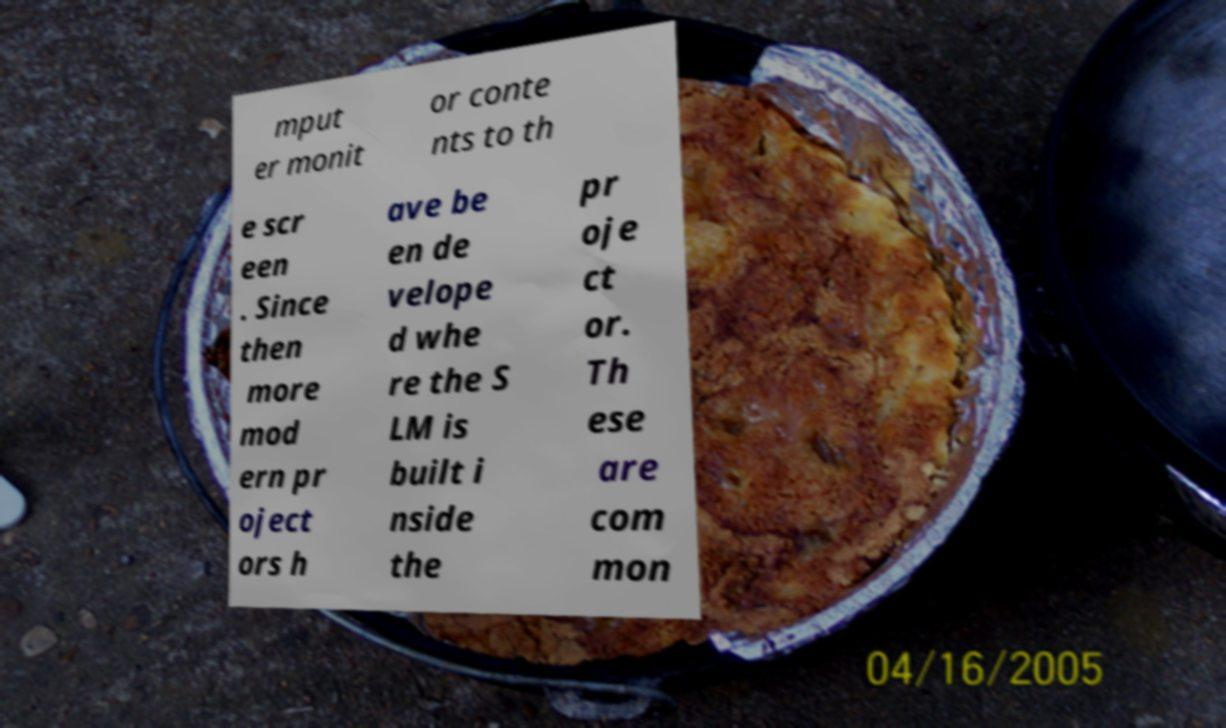Can you accurately transcribe the text from the provided image for me? mput er monit or conte nts to th e scr een . Since then more mod ern pr oject ors h ave be en de velope d whe re the S LM is built i nside the pr oje ct or. Th ese are com mon 